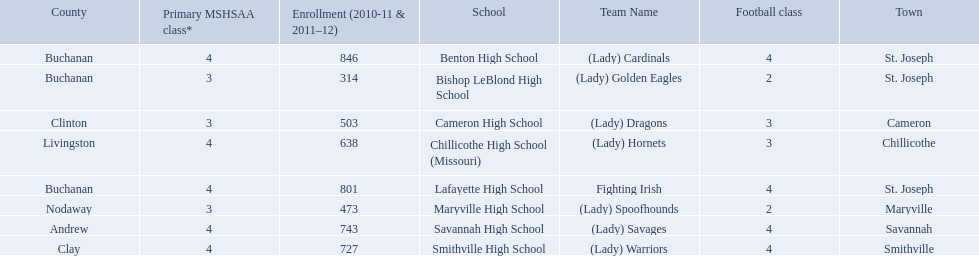What are all of the schools? Benton High School, Bishop LeBlond High School, Cameron High School, Chillicothe High School (Missouri), Lafayette High School, Maryville High School, Savannah High School, Smithville High School. How many football classes do they have? 4, 2, 3, 3, 4, 2, 4, 4. What about their enrollment? 846, 314, 503, 638, 801, 473, 743, 727. Which schools have 3 football classes? Cameron High School, Chillicothe High School (Missouri). And of those schools, which has 638 students? Chillicothe High School (Missouri). 